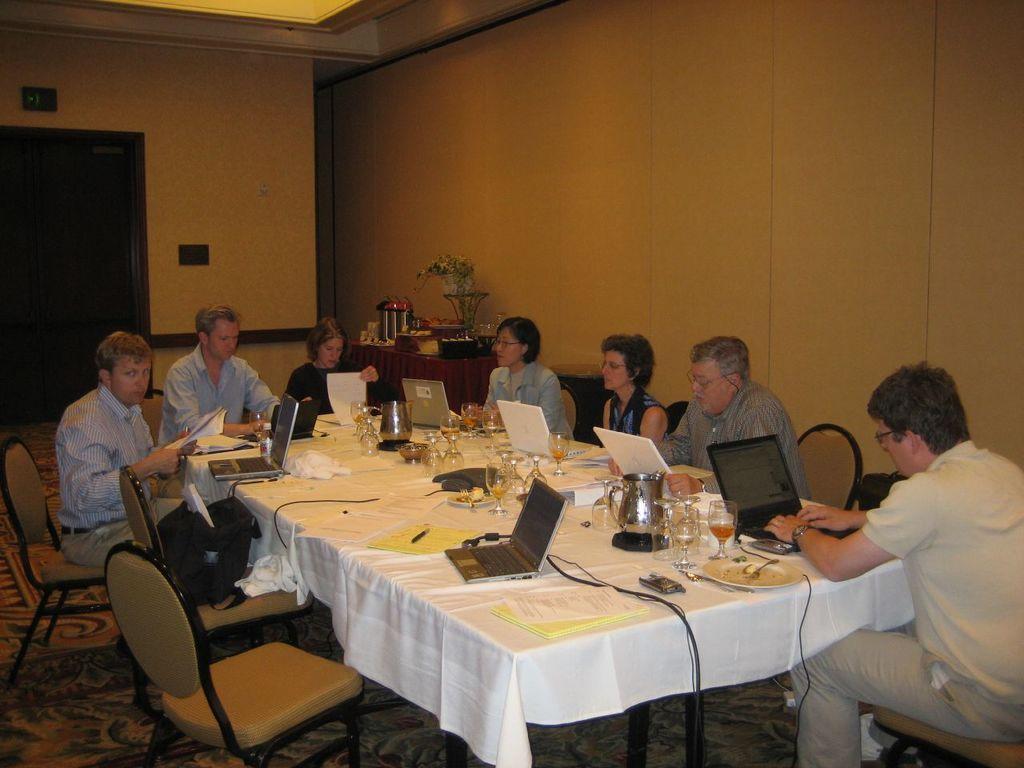How would you summarize this image in a sentence or two? There are group of people sitting in chairs and there is a table in front of them. The table consists of laptops,books,pens,glasses and juice and the background is gold in color. 